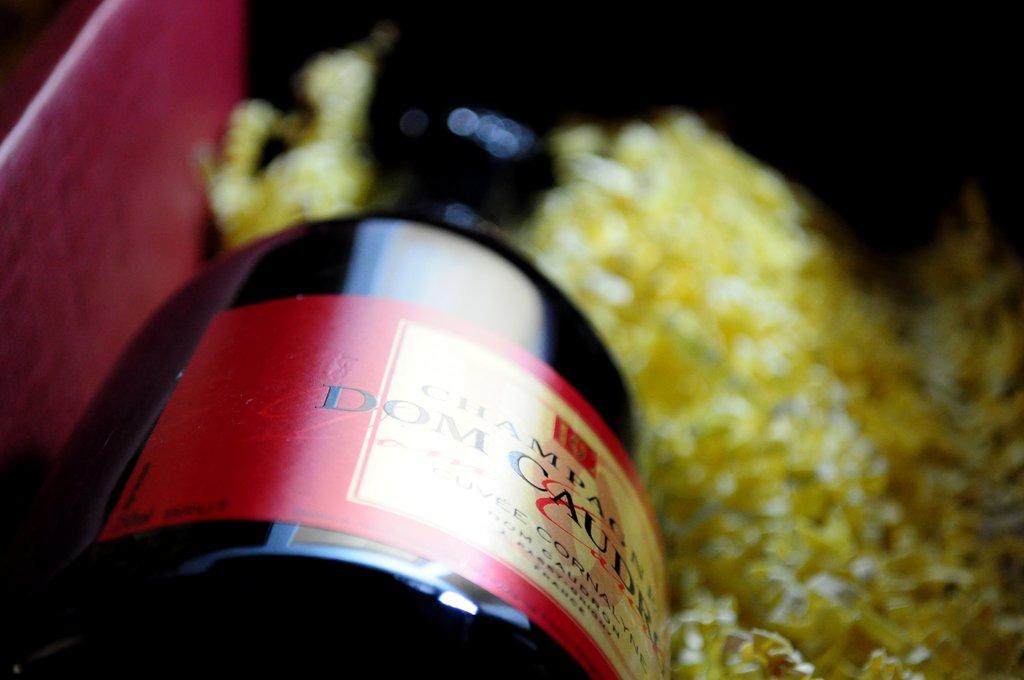What country was this bottled in?
Make the answer very short. France. 